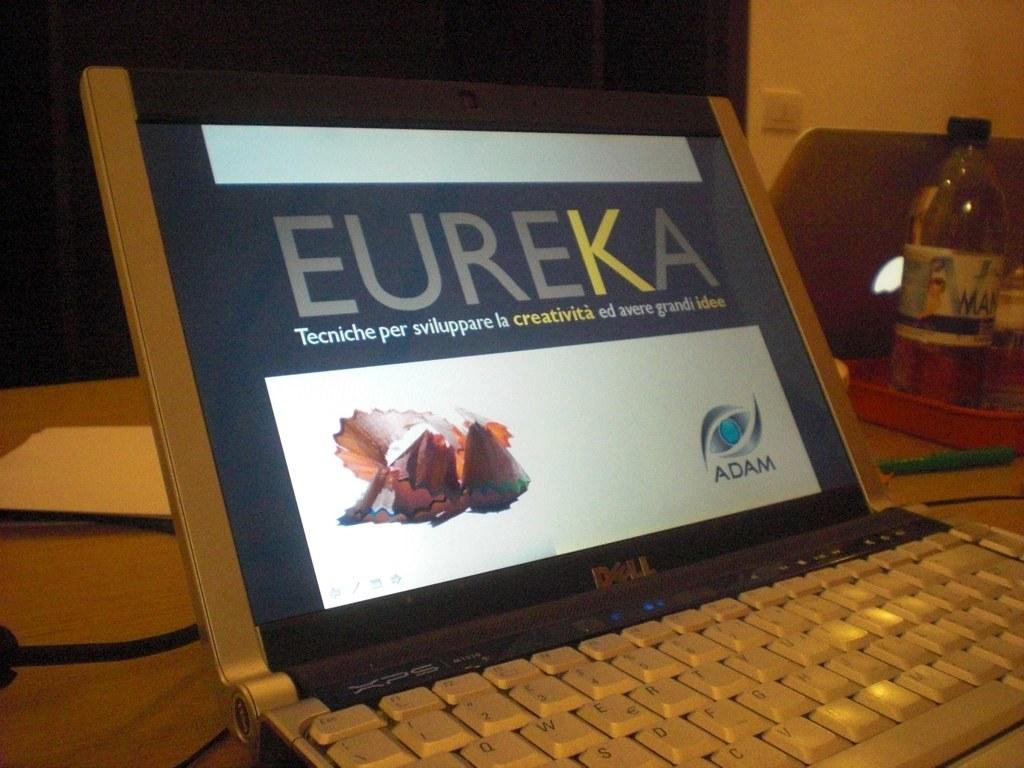Which one would you go for eureka or apple?
Provide a short and direct response. Answering does not require reading text in the image. What does the company adam make?
Offer a very short reply. Eureka. 